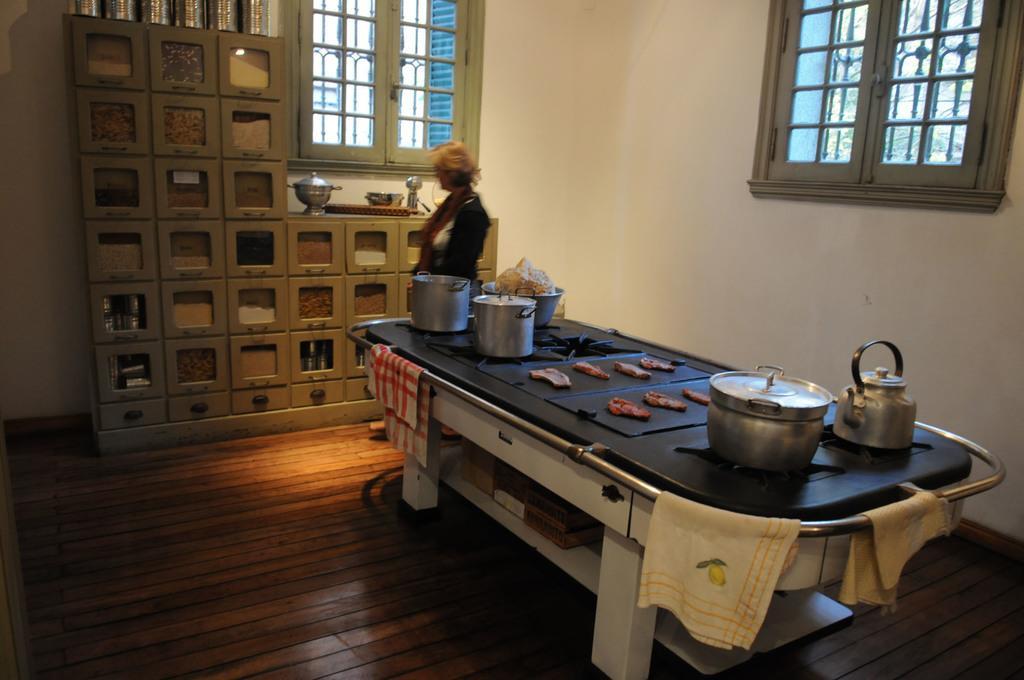Can you describe this image briefly? In this image I can see a black colour thing and on it I can see few clothes, few utensils and food. In the background I can see a woman is standing and a near her I can see number of boxes and in these boxes I can see things. I can also see few more utensils on these boxes. In the background and on the right side of this image I can see windows. 